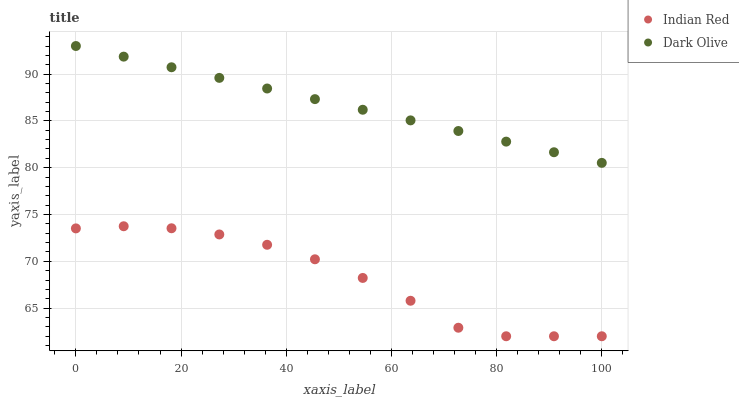Does Indian Red have the minimum area under the curve?
Answer yes or no. Yes. Does Dark Olive have the maximum area under the curve?
Answer yes or no. Yes. Does Indian Red have the maximum area under the curve?
Answer yes or no. No. Is Dark Olive the smoothest?
Answer yes or no. Yes. Is Indian Red the roughest?
Answer yes or no. Yes. Is Indian Red the smoothest?
Answer yes or no. No. Does Indian Red have the lowest value?
Answer yes or no. Yes. Does Dark Olive have the highest value?
Answer yes or no. Yes. Does Indian Red have the highest value?
Answer yes or no. No. Is Indian Red less than Dark Olive?
Answer yes or no. Yes. Is Dark Olive greater than Indian Red?
Answer yes or no. Yes. Does Indian Red intersect Dark Olive?
Answer yes or no. No. 